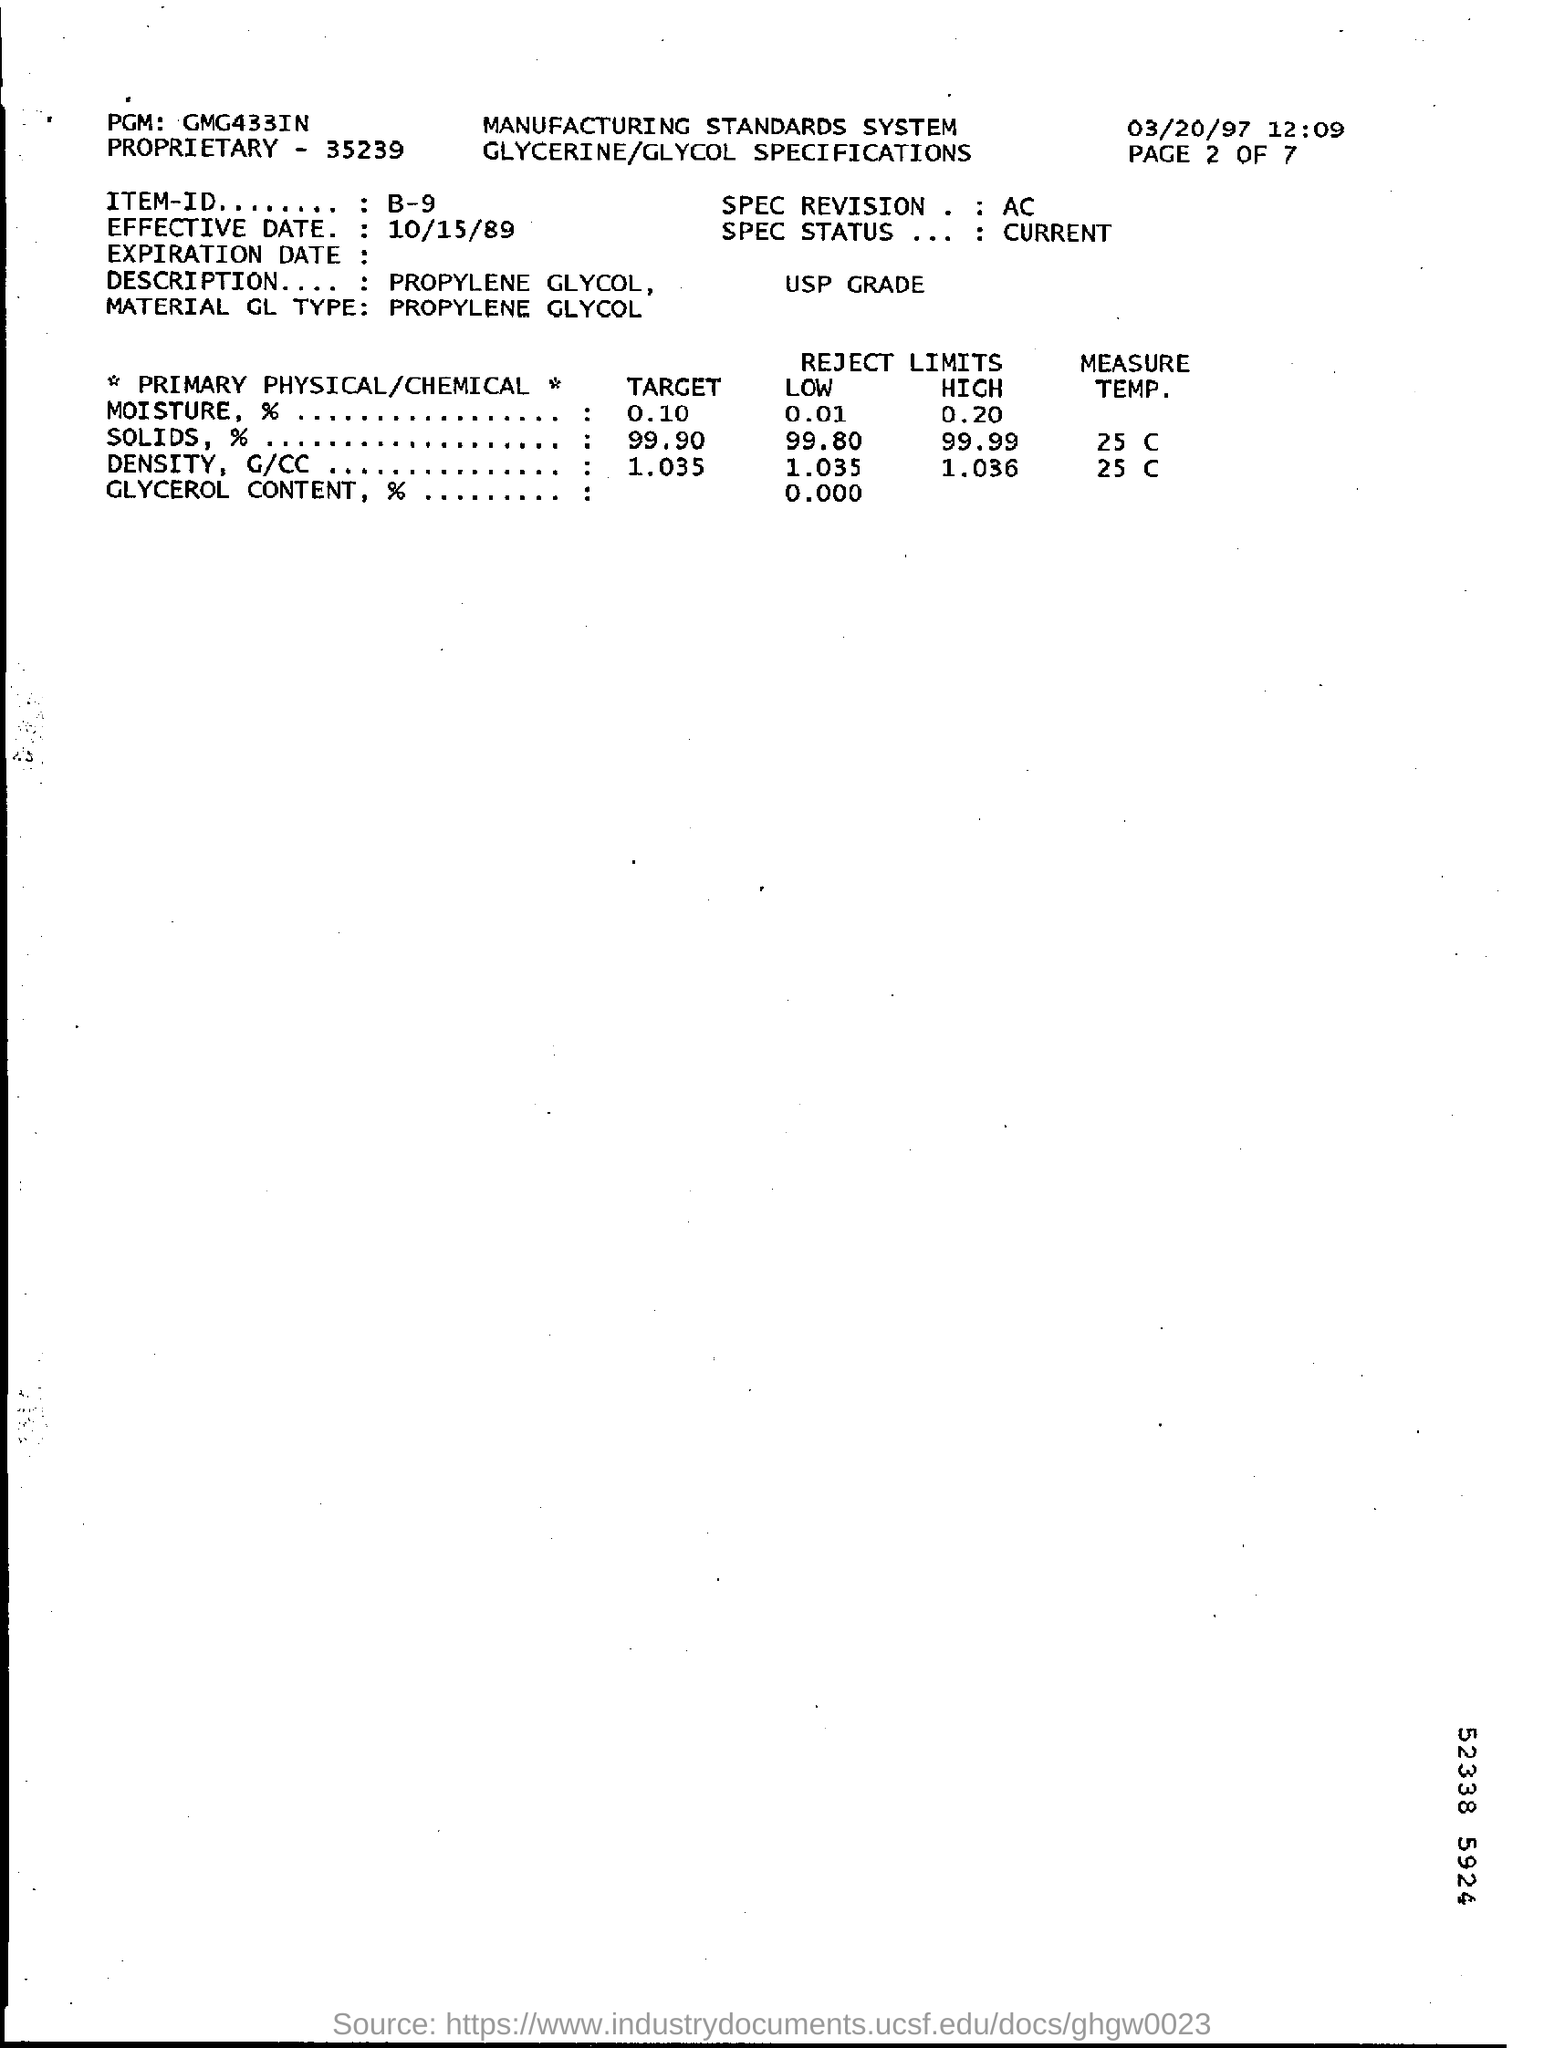What is the date mentioned in the top right of the document ?
Provide a succinct answer. 03/20/97. What is the Effective Date ?
Provide a short and direct response. 10/15/89. What is mentioned in the Description Field ?
Make the answer very short. Propylene glycol, USP grade. What is the Target of Moisture ?
Offer a terse response. 0.10. What is written in the PGM Field ?
Your response must be concise. GMG433IN. What is mentioned in the Proprietary Field ?
Keep it short and to the point. 35239. What is  written in the Item-ID Field ?
Keep it short and to the point. B-9. What is mentioned in the SPEC REVISION Field ?
Provide a succinct answer. AC. What is Written in the SPEC Status Field ?
Make the answer very short. CURRENT. 